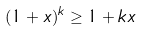Convert formula to latex. <formula><loc_0><loc_0><loc_500><loc_500>( 1 + x ) ^ { k } \geq 1 + k x</formula> 